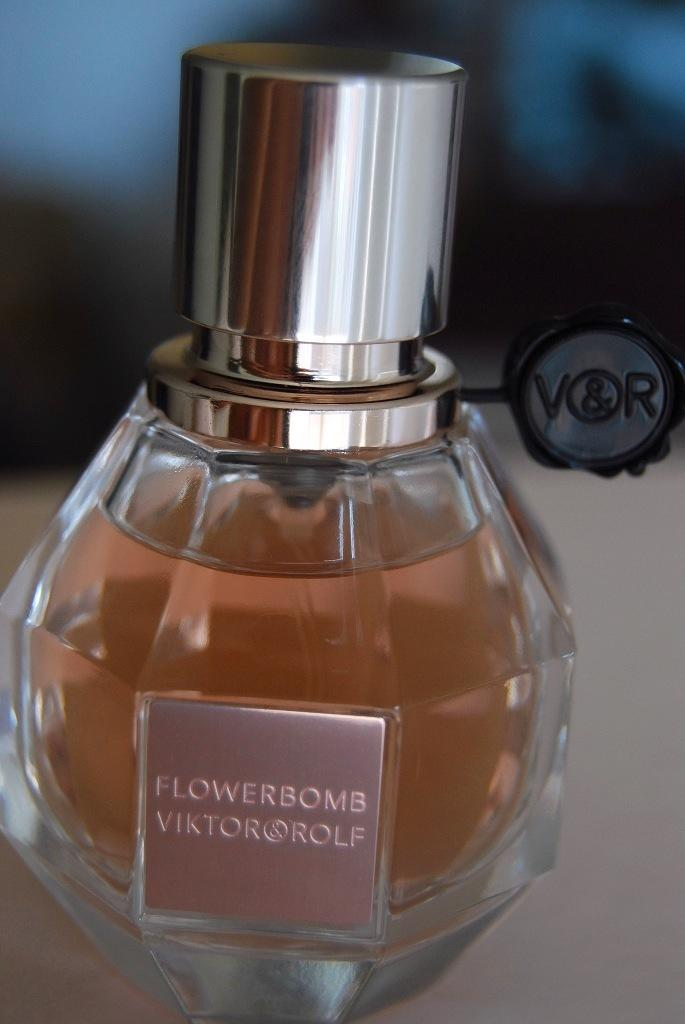What object is present in the image? There is a bottle in the image. What is the color of the bottle? The bottle is white in color. What is inside the bottle? The bottle contains a yellow liquid. Is there any label or tag on the bottle? Yes, there is a black tag on the bottle. What letters can be seen on the tag? The letters "t" and "r" are written on the tag. Can you see a crow sitting on the swing in the image? There is no swing or crow present in the image. 